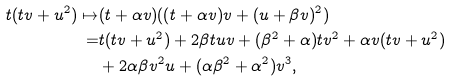Convert formula to latex. <formula><loc_0><loc_0><loc_500><loc_500>t ( t v + u ^ { 2 } ) \mapsto & ( t + \alpha v ) ( ( t + \alpha v ) v + ( u + \beta v ) ^ { 2 } ) \\ = & t ( t v + u ^ { 2 } ) + 2 \beta t u v + ( \beta ^ { 2 } + \alpha ) t v ^ { 2 } + \alpha v ( t v + u ^ { 2 } ) \\ & + 2 \alpha \beta v ^ { 2 } u + ( \alpha \beta ^ { 2 } + \alpha ^ { 2 } ) v ^ { 3 } ,</formula> 